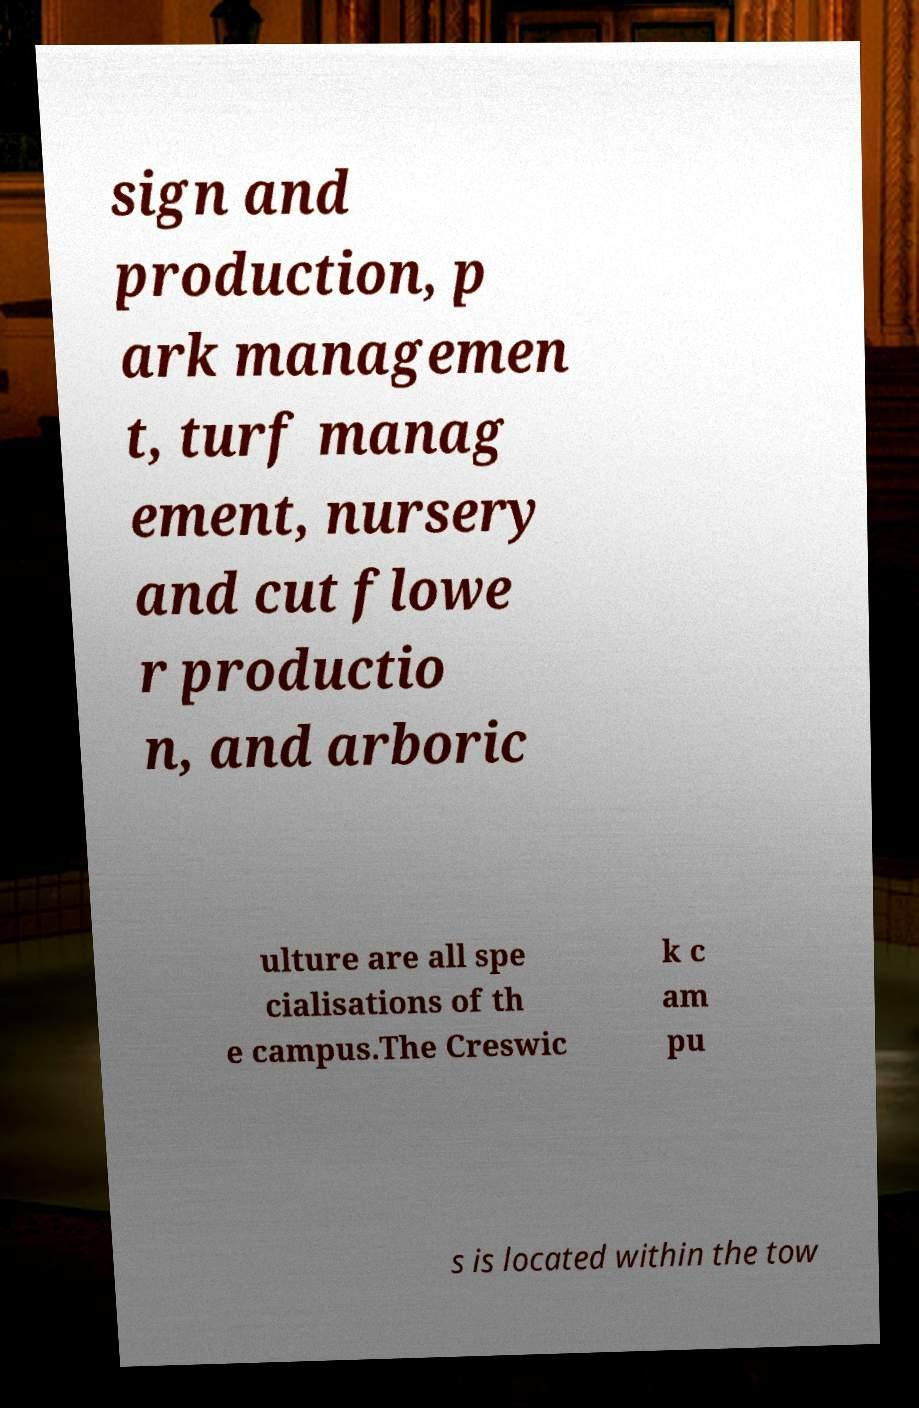There's text embedded in this image that I need extracted. Can you transcribe it verbatim? sign and production, p ark managemen t, turf manag ement, nursery and cut flowe r productio n, and arboric ulture are all spe cialisations of th e campus.The Creswic k c am pu s is located within the tow 